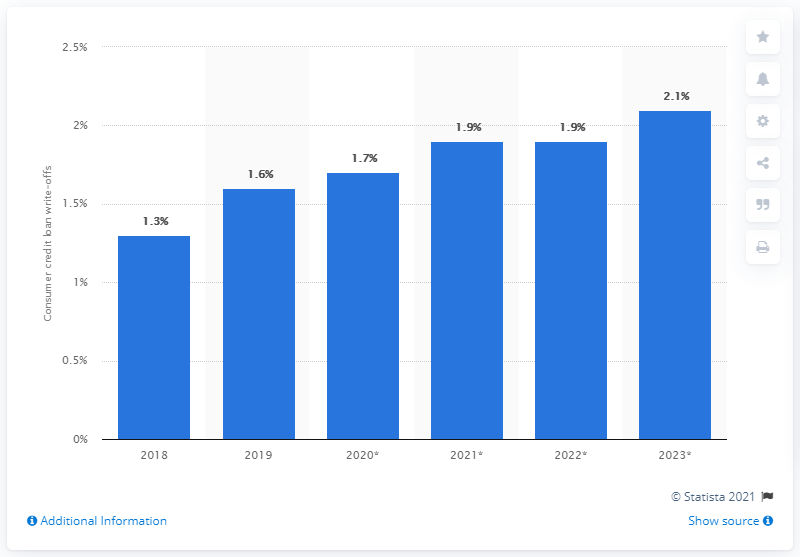Give some essential details in this illustration. In 2018, a total of 1.3% of consumer credit loans were written off, indicating a decrease from the previous year. A significant percentage of consumer credit loans are expected to be written off by 2023. In particular, 2.1% of these loans are projected to be written off. 